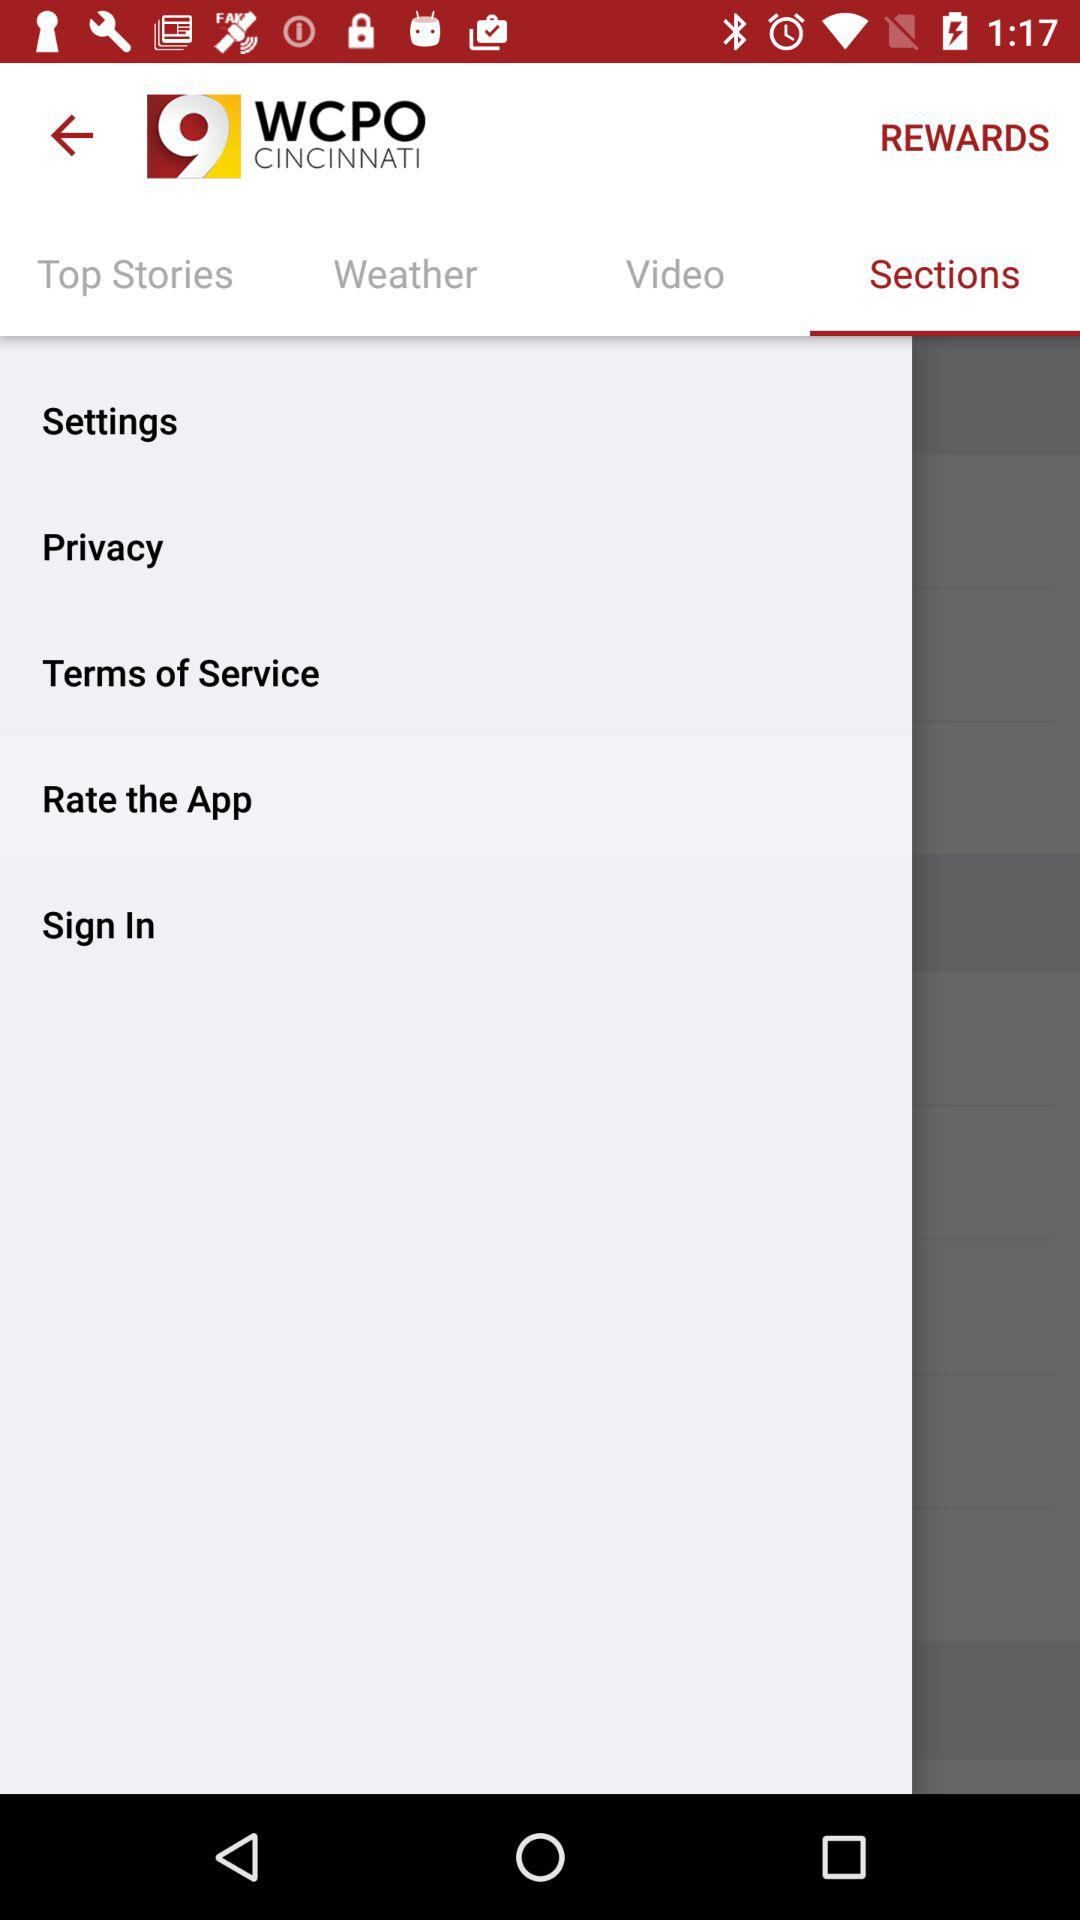Which tab is currently selected? The selected tab is "Sections". 